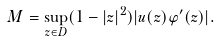<formula> <loc_0><loc_0><loc_500><loc_500>M = \sup _ { z \in D } ( 1 - | z | ^ { 2 } ) | u ( z ) \varphi ^ { \prime } ( z ) | .</formula> 